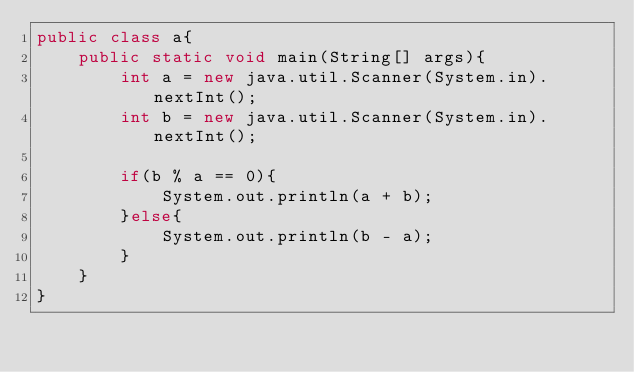<code> <loc_0><loc_0><loc_500><loc_500><_Java_>public class a{
    public static void main(String[] args){
        int a = new java.util.Scanner(System.in).nextInt();
        int b = new java.util.Scanner(System.in).nextInt();

        if(b % a == 0){
            System.out.println(a + b);
        }else{
            System.out.println(b - a);
        }
    }
}</code> 